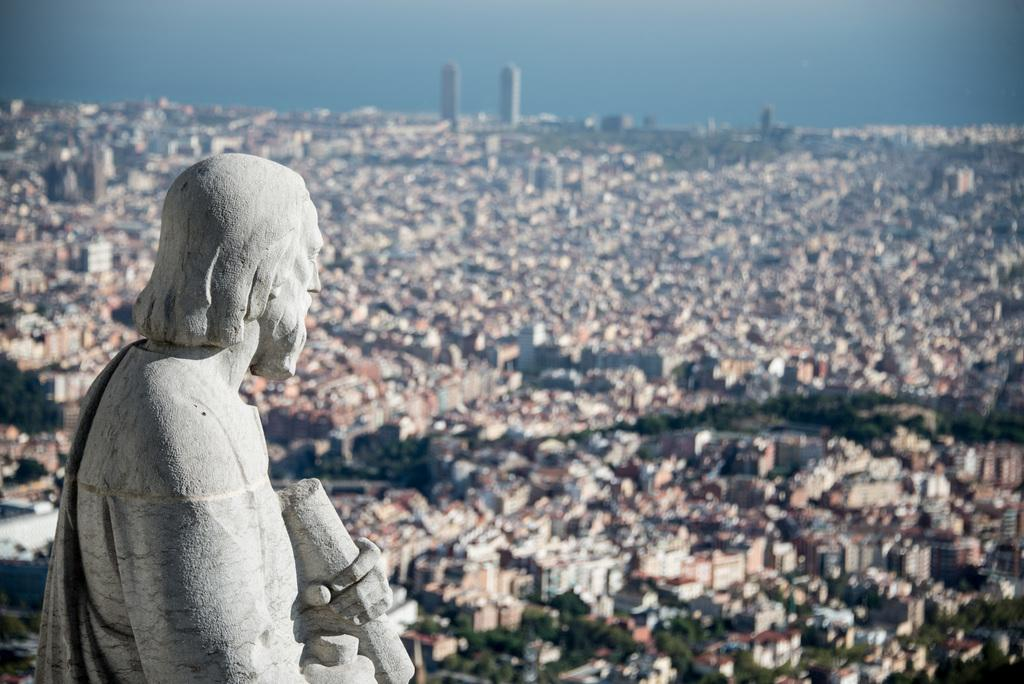What is the main subject in the image? There is a statue in the image. What type of natural elements can be seen in the image? There are trees in the image. What type of man-made structures are visible in the image? There are buildings in the image. What is visible at the top of the image? The sky is visible at the top of the image. What type of alarm can be heard going off in the image? There is no alarm present in the image, and therefore no sound can be heard. 